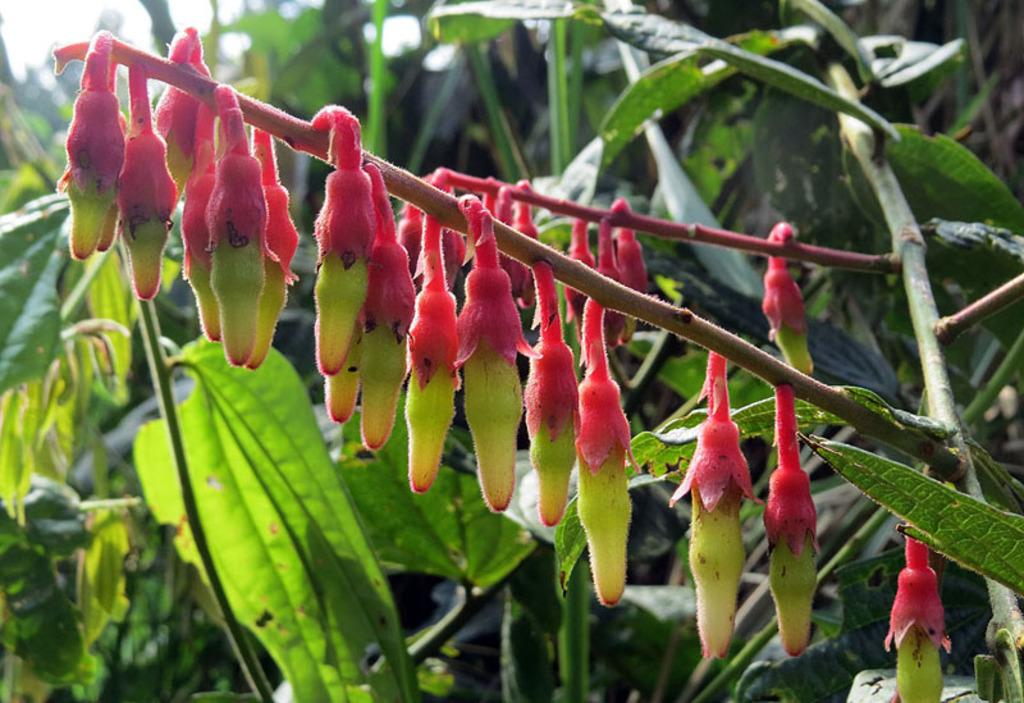What type of living organisms can be seen in the image? Plants can be seen in the image. Can you describe any specific features of the plants? There are flower buds in the image. What type of silver material can be seen in the image? There is no silver material present in the image; it features plants and flower buds. What scent is associated with the plants in the image? The image does not provide any information about the scent of the plants, so it cannot be determined from the picture. 